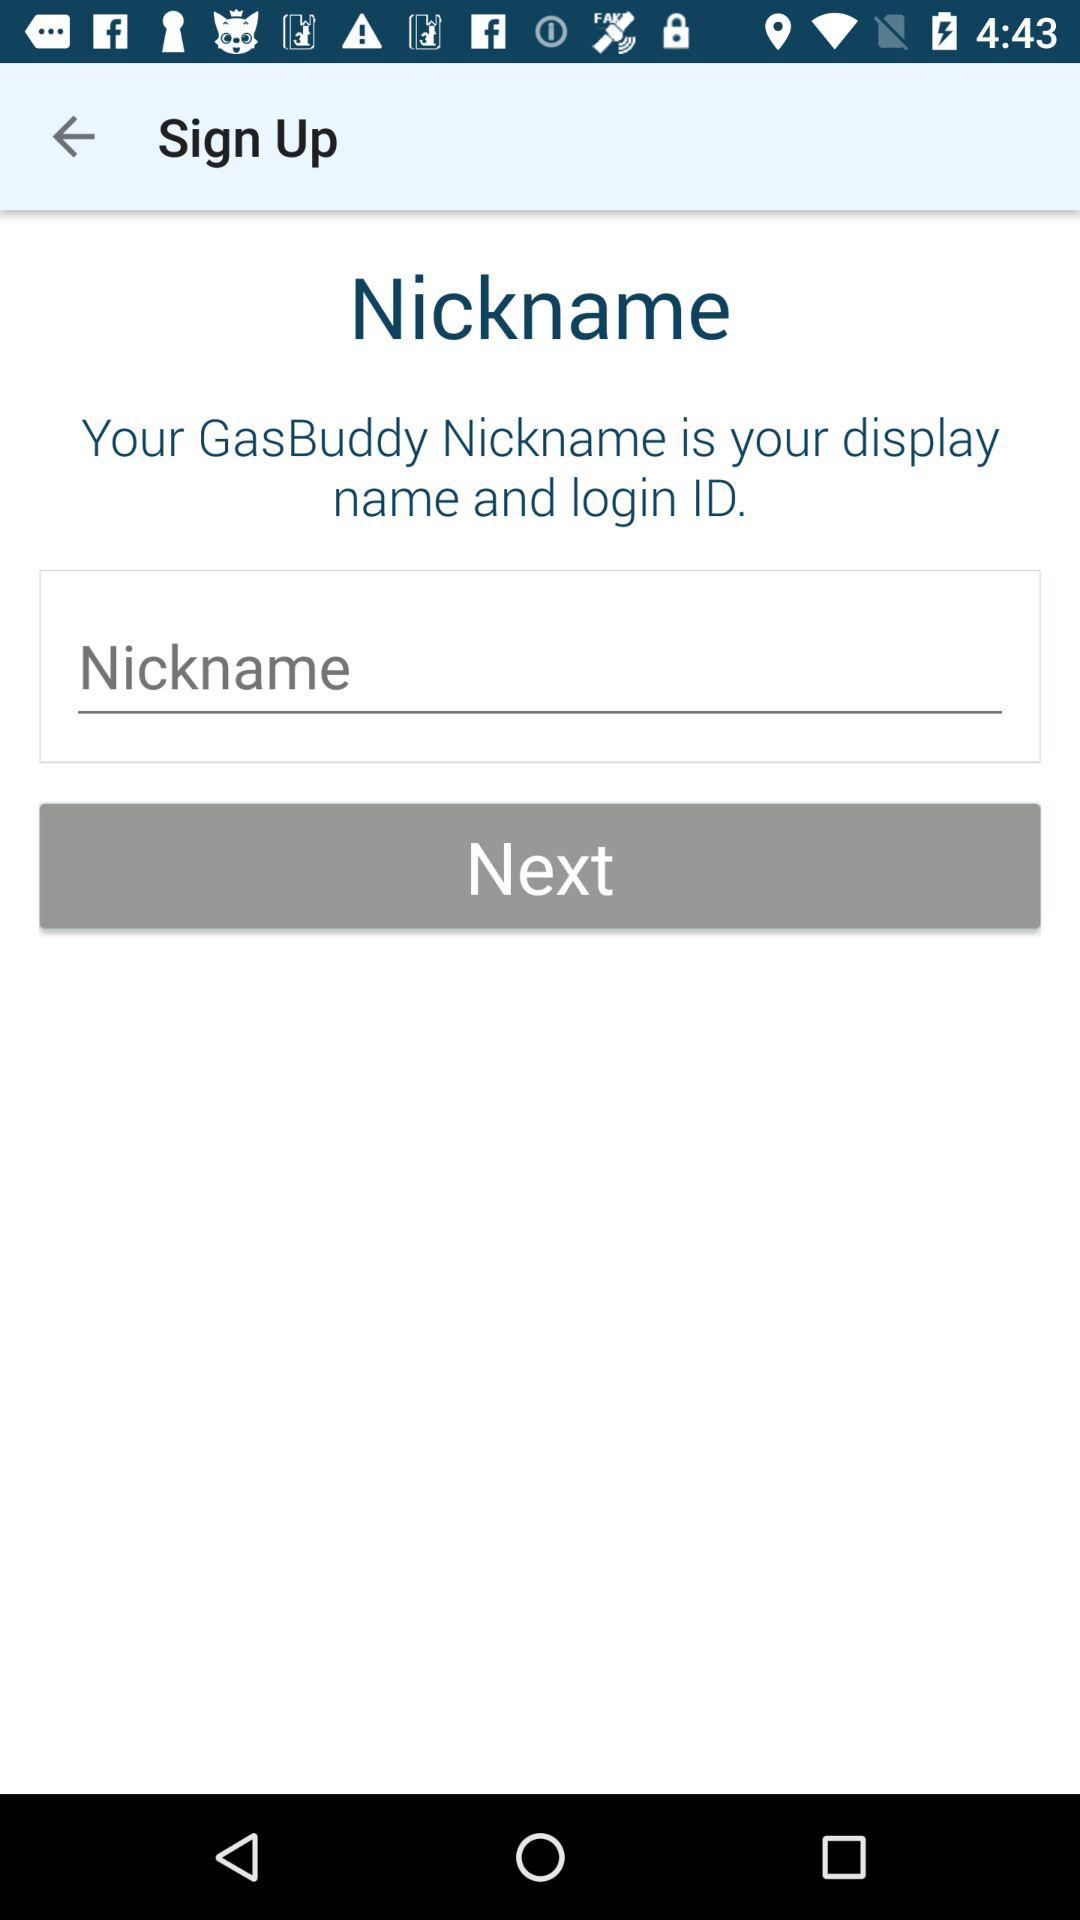What is the name of the application? The name of the application is "GasBuddy". 